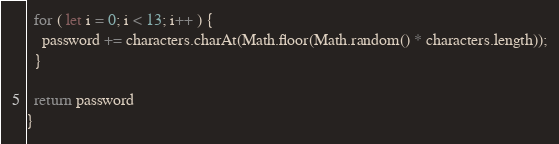Convert code to text. <code><loc_0><loc_0><loc_500><loc_500><_TypeScript_>  for ( let i = 0; i < 13; i++ ) {
    password += characters.charAt(Math.floor(Math.random() * characters.length));
  }

  return password
}</code> 